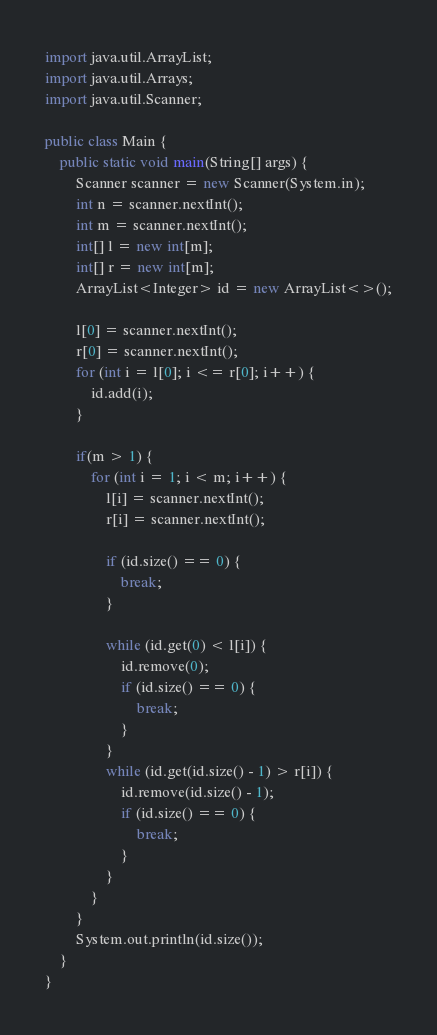<code> <loc_0><loc_0><loc_500><loc_500><_Java_>import java.util.ArrayList;
import java.util.Arrays;
import java.util.Scanner;

public class Main {
    public static void main(String[] args) {
        Scanner scanner = new Scanner(System.in);
        int n = scanner.nextInt();
        int m = scanner.nextInt();
        int[] l = new int[m];
        int[] r = new int[m];
        ArrayList<Integer> id = new ArrayList<>();

        l[0] = scanner.nextInt();
        r[0] = scanner.nextInt();
        for (int i = l[0]; i <= r[0]; i++) {
            id.add(i);
        }

        if(m > 1) {
            for (int i = 1; i < m; i++) {
                l[i] = scanner.nextInt();
                r[i] = scanner.nextInt();

                if (id.size() == 0) {
                    break;
                }

                while (id.get(0) < l[i]) {
                    id.remove(0);
                    if (id.size() == 0) {
                        break;
                    }
                }
                while (id.get(id.size() - 1) > r[i]) {
                    id.remove(id.size() - 1);
                    if (id.size() == 0) {
                        break;
                    }
                }
            }
        }
        System.out.println(id.size());
    }
}</code> 